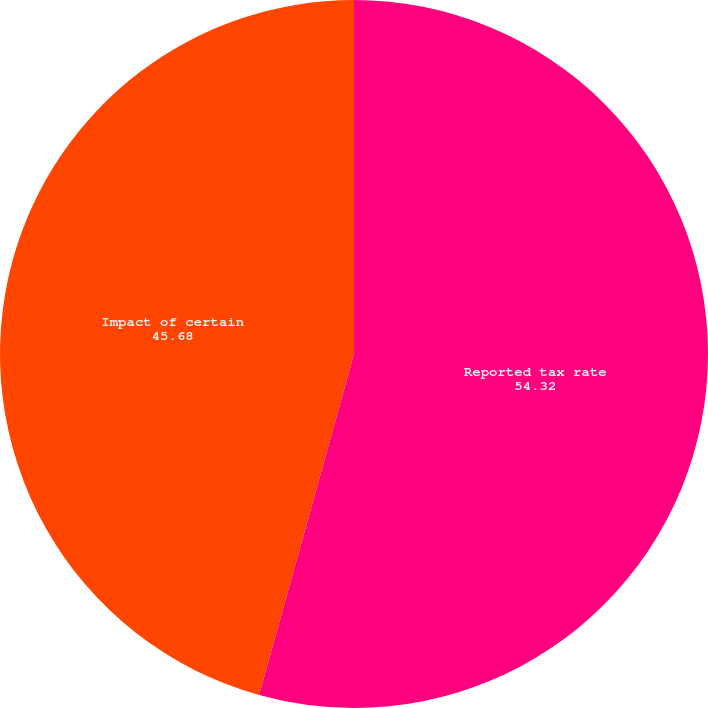<chart> <loc_0><loc_0><loc_500><loc_500><pie_chart><fcel>Reported tax rate<fcel>Impact of certain<nl><fcel>54.32%<fcel>45.68%<nl></chart> 